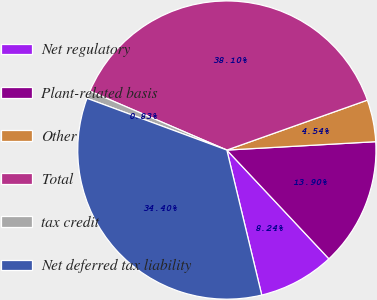Convert chart to OTSL. <chart><loc_0><loc_0><loc_500><loc_500><pie_chart><fcel>Net regulatory<fcel>Plant-related basis<fcel>Other<fcel>Total<fcel>tax credit<fcel>Net deferred tax liability<nl><fcel>8.24%<fcel>13.9%<fcel>4.54%<fcel>38.1%<fcel>0.83%<fcel>34.4%<nl></chart> 